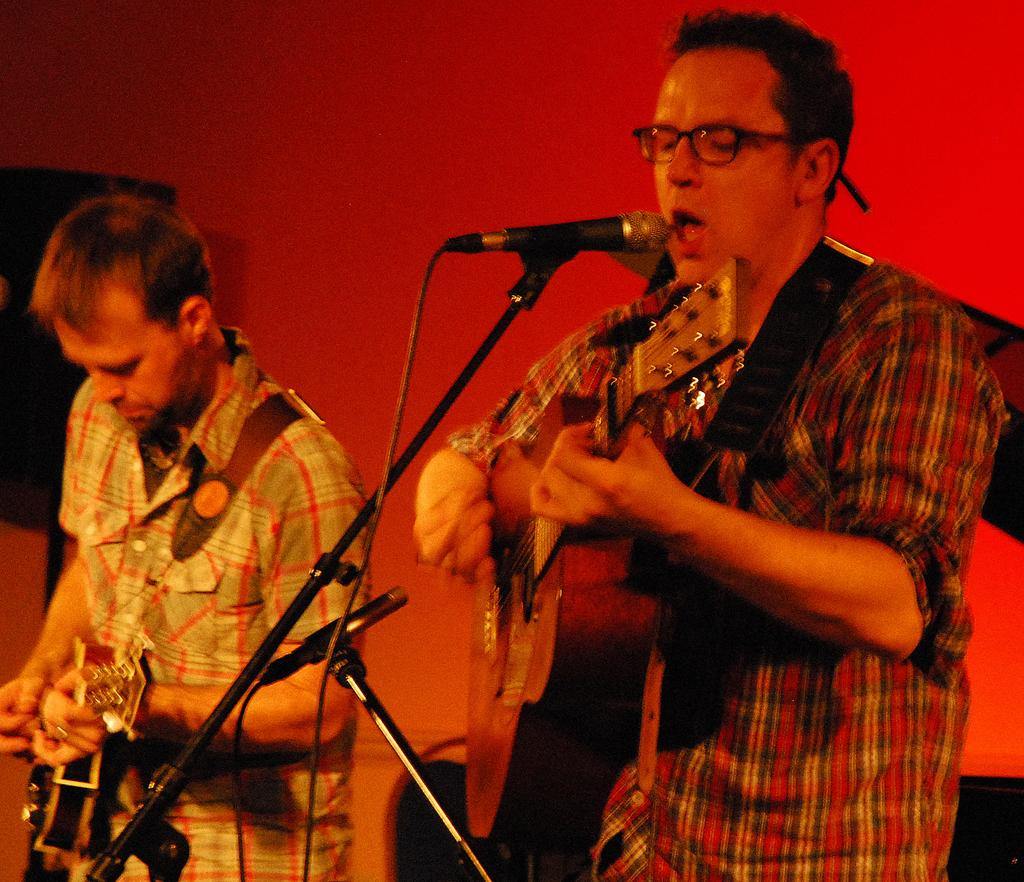How many people are in the image? There are two people in the image. What are the two people doing? The two people are standing and playing the guitar. What object is present for amplifying sound? There is a microphone in the image. What is used to hold the guitar while playing? There is a stand in the image. What color is the wall in the background? The wall in the background has a red color. What scientific experiment is being conducted in the image? There is no scientific experiment present in the image; it features two people playing the guitar. What is the plot of the story unfolding in the image? There is no story or plot depicted in the image; it simply shows two people playing the guitar. 